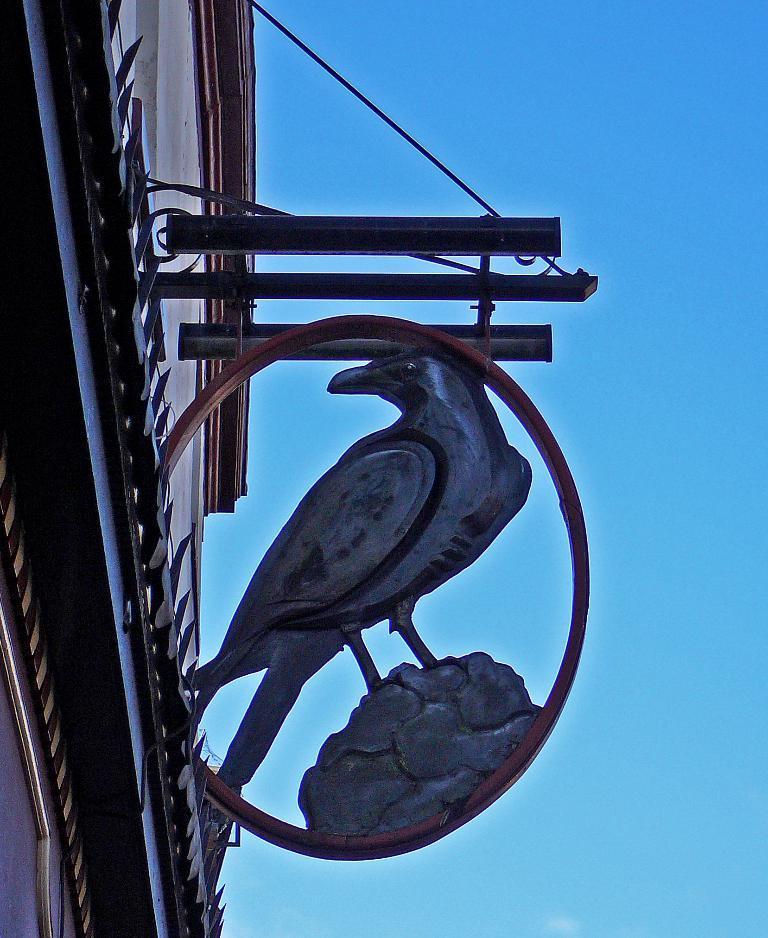Please provide a concise description of this image. In this image we can see there is a statue attached to the rod and we can see the wall with a design and sky in the background. 